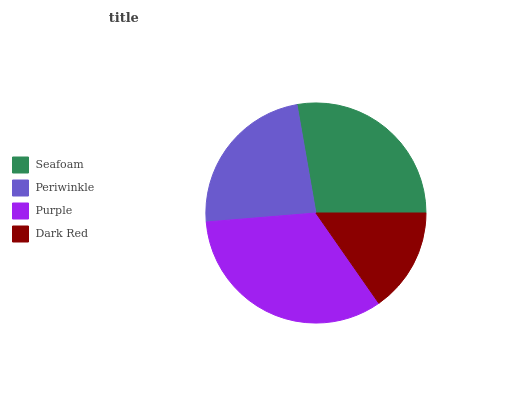Is Dark Red the minimum?
Answer yes or no. Yes. Is Purple the maximum?
Answer yes or no. Yes. Is Periwinkle the minimum?
Answer yes or no. No. Is Periwinkle the maximum?
Answer yes or no. No. Is Seafoam greater than Periwinkle?
Answer yes or no. Yes. Is Periwinkle less than Seafoam?
Answer yes or no. Yes. Is Periwinkle greater than Seafoam?
Answer yes or no. No. Is Seafoam less than Periwinkle?
Answer yes or no. No. Is Seafoam the high median?
Answer yes or no. Yes. Is Periwinkle the low median?
Answer yes or no. Yes. Is Periwinkle the high median?
Answer yes or no. No. Is Purple the low median?
Answer yes or no. No. 